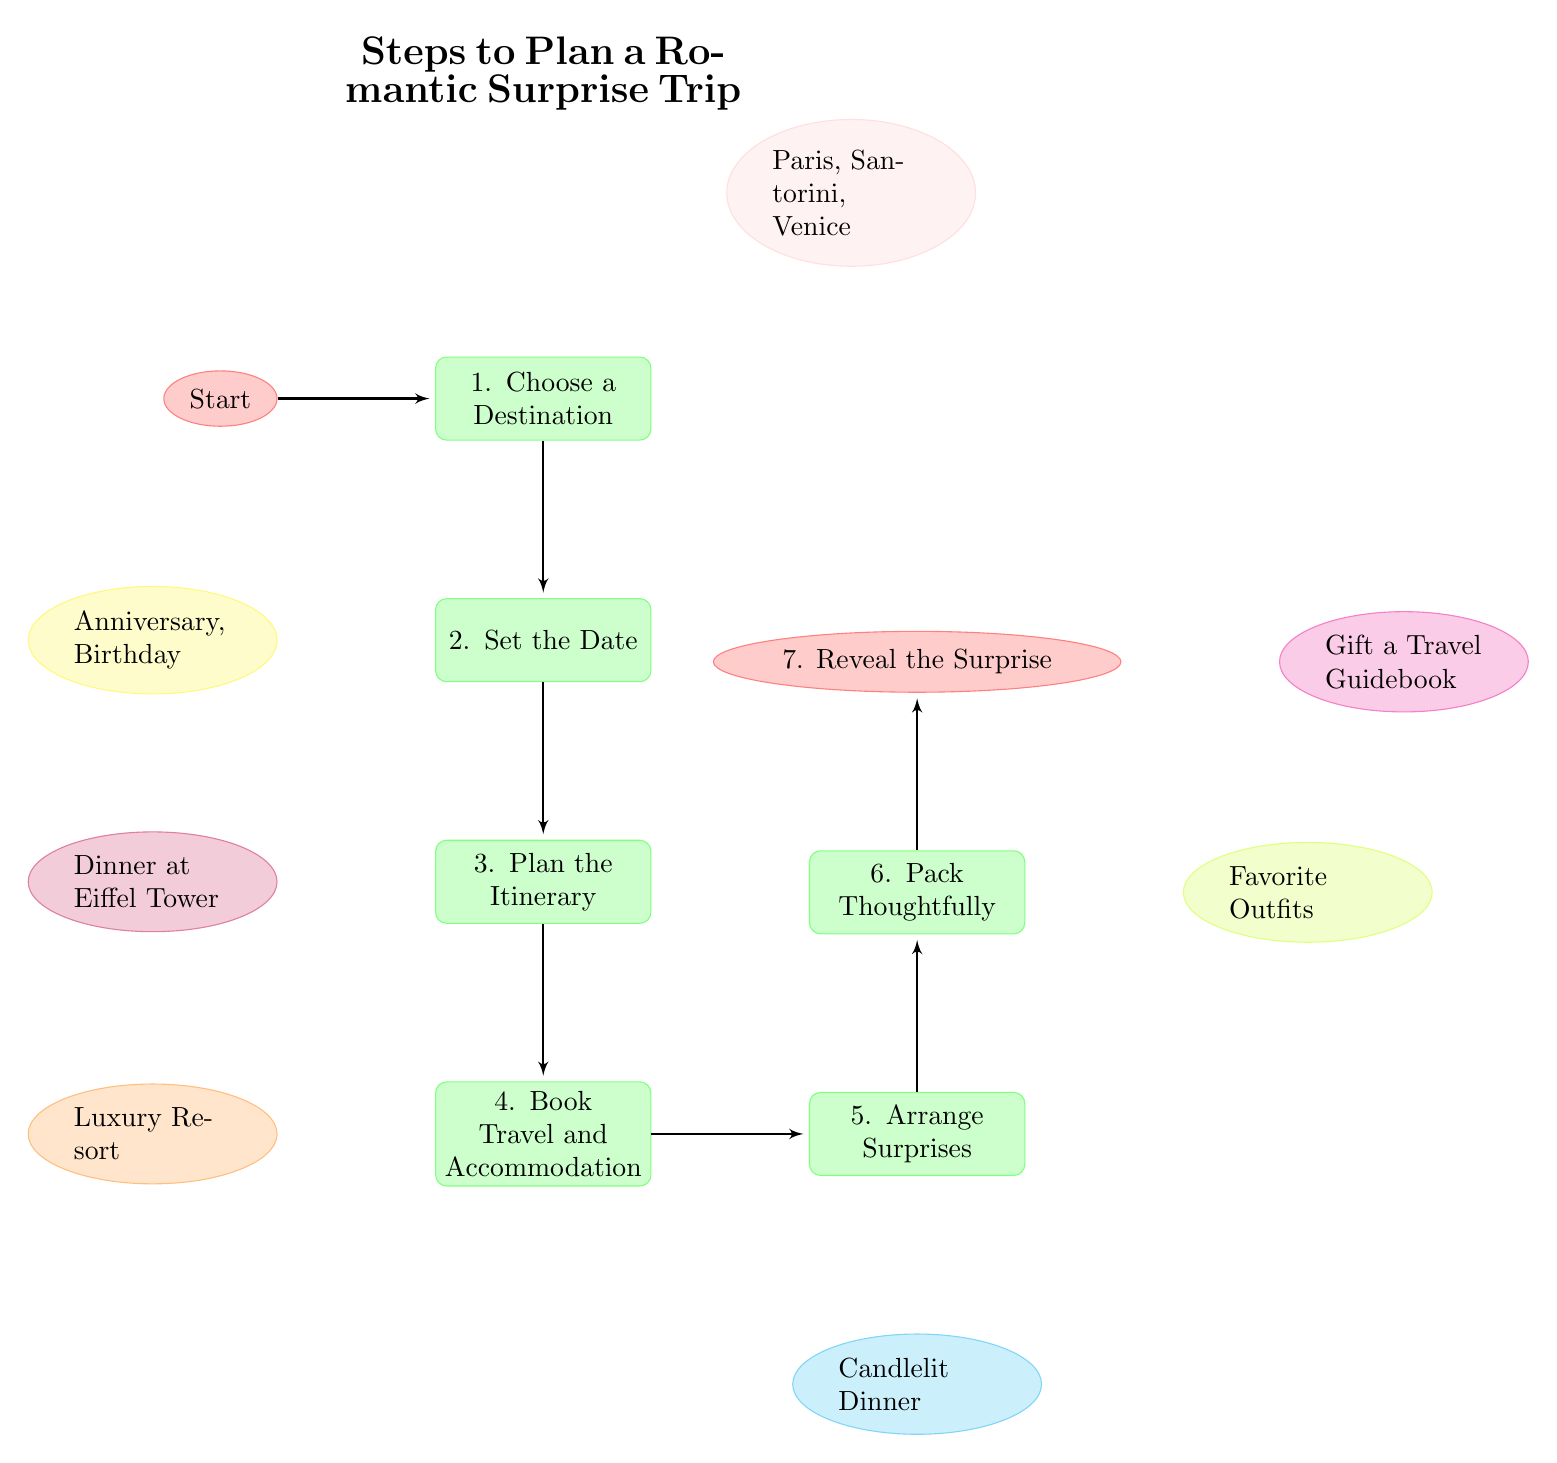What is the first step in planning a romantic surprise trip? The first node in the diagram indicates that the initial step is to choose a destination.
Answer: Choose a Destination How many total steps are there in the romantic trip planning process? By counting the nodes listed in the diagram, there are a total of 7 steps.
Answer: 7 What types of locations are suggested for the destination? The diagram provides suggestions such as Paris, Santorini, and Venice as romantic destinations.
Answer: Paris, Santorini, Venice What activities are planned in the third step? The third step refers to planning the itinerary, which includes romantic activities such as dinner at the Eiffel Tower.
Answer: Dinner at Eiffel Tower What should you do in the fourth step? The fourth node indicates that the task is to book travel and accommodation arrangements.
Answer: Book Travel and Accommodation What special surprises can be arranged, according to the fifth step? The fifth step highlights arranging surprises, with examples like a candlelit dinner.
Answer: Candlelit Dinner How are the surprises revealed in the last step? The last node suggests revealing the surprise trip through memorable methods such as gifting a travel guidebook.
Answer: Gift a Travel Guidebook What node is directly below the “Book Travel and Accommodation” step? Looking at the arrangement, the step directly below "Book Travel and Accommodation" is "Arrange Surprises."
Answer: Arrange Surprises What is the main purpose of the entire diagram? The purpose of the diagram is to provide a step-by-step guide for planning a romantic surprise trip, ensuring each aspect is covered for a delightful experience.
Answer: Steps to Plan a Romantic Surprise Trip 